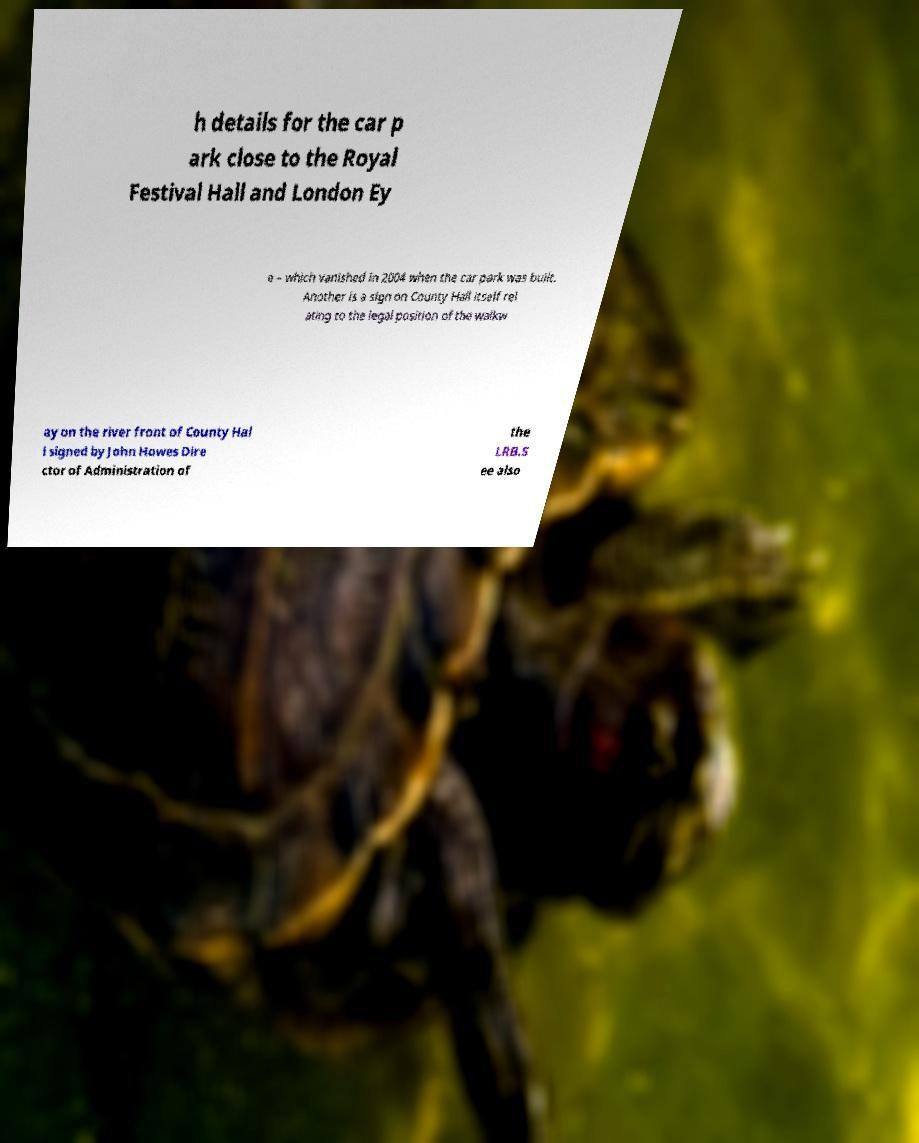Could you extract and type out the text from this image? h details for the car p ark close to the Royal Festival Hall and London Ey e – which vanished in 2004 when the car park was built. Another is a sign on County Hall itself rel ating to the legal position of the walkw ay on the river front of County Hal l signed by John Howes Dire ctor of Administration of the LRB.S ee also 